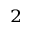<formula> <loc_0><loc_0><loc_500><loc_500>_ { 2 }</formula> 